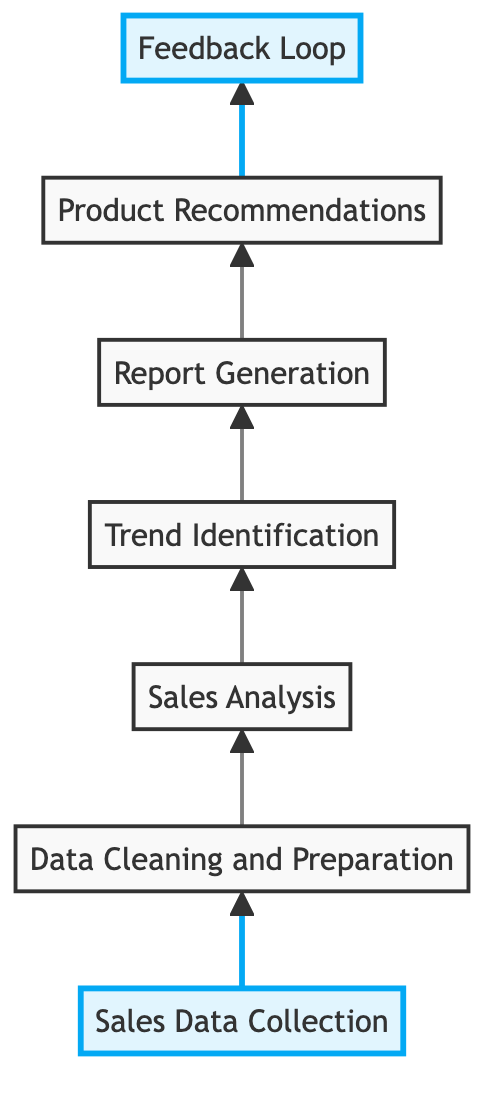What is the first step in the sales data analysis workflow? The first step in the workflow is represented by the node labeled "Sales Data Collection." It is the starting point before any other processes take place.
Answer: Sales Data Collection How many total nodes are present in the diagram? By counting the distinct steps represented in the diagram, we have seven nodes: Sales Data Collection, Data Cleaning and Preparation, Sales Analysis, Trend Identification, Report Generation, Product Recommendations, and Feedback Loop.
Answer: 7 What follows Sales Analysis in the workflow? Based on the flow direction in the diagram, Sales Analysis is followed by Trend Identification. It indicates a progression from analyzing sales data to identifying patterns.
Answer: Trend Identification Which node in the chart is highlighted? The nodes with the highlight class are "Sales Data Collection" and "Feedback Loop." They are visually distinguished from the others to emphasize their importance.
Answer: Sales Data Collection, Feedback Loop What type of analysis is involved after Data Cleaning and Preparation? The analysis step that occurs after Data Cleaning and Preparation is known as Sales Analysis. It focuses on assessing the quality of the cleaned data for meaningful insights.
Answer: Sales Analysis What is the purpose of the Feedback Loop in the workflow? The Feedback Loop serves to collect customer feedback on product recommendations, which is used to refine sales strategies and improve future offerings. This step is vital for the iterative process of enhancing customer satisfaction.
Answer: Collect customer feedback How many direct connections lead from Trend Identification? There is one direct connection from Trend Identification to Report Generation in the workflow. This indicates that after identifying trends, the next step is to generate reports.
Answer: 1 What is the last step in the sales data analysis workflow? The final node in the workflow is Product Recommendations, which signifies that after analyzing data and generating reports, personalized product recommendations are made to customers.
Answer: Product Recommendations Which element in the workflow is responsible for generating reports? The element specifically responsible for generating reports based on the analyzed sales data is labeled "Report Generation." This is a key output step in the process.
Answer: Report Generation What does the arrow between Report Generation and Recommendations indicate? The arrow indicates a flow of information, meaning that the outputs generated from the Report Generation step directly inform the Product Recommendations step. This connection shows a progression from analysis to actionable decisions.
Answer: Flow of information 